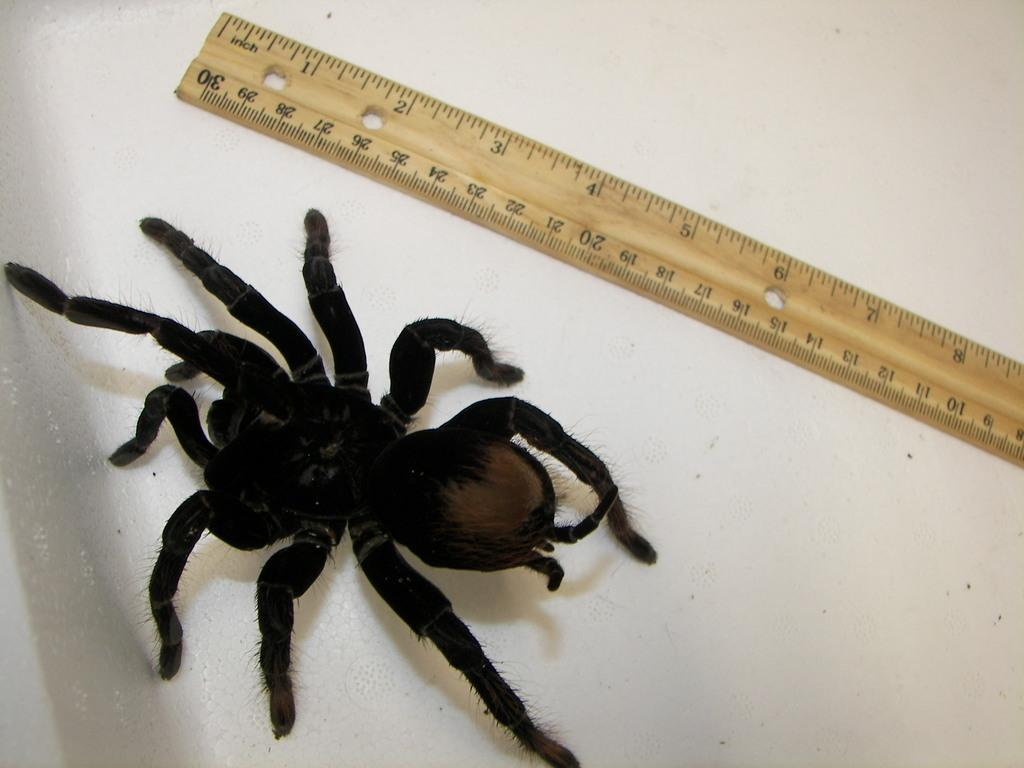What is the color of the spider in the image? The spider in the image is black colored. What is placed beside the spider? There is a scale beside the spider. What color is the surface on which the spider is resting? The spider is on a white color surface. What type of juice can be seen in the image? There is no juice present in the image; it features a black colored spider on a white surface with a scale beside it. 